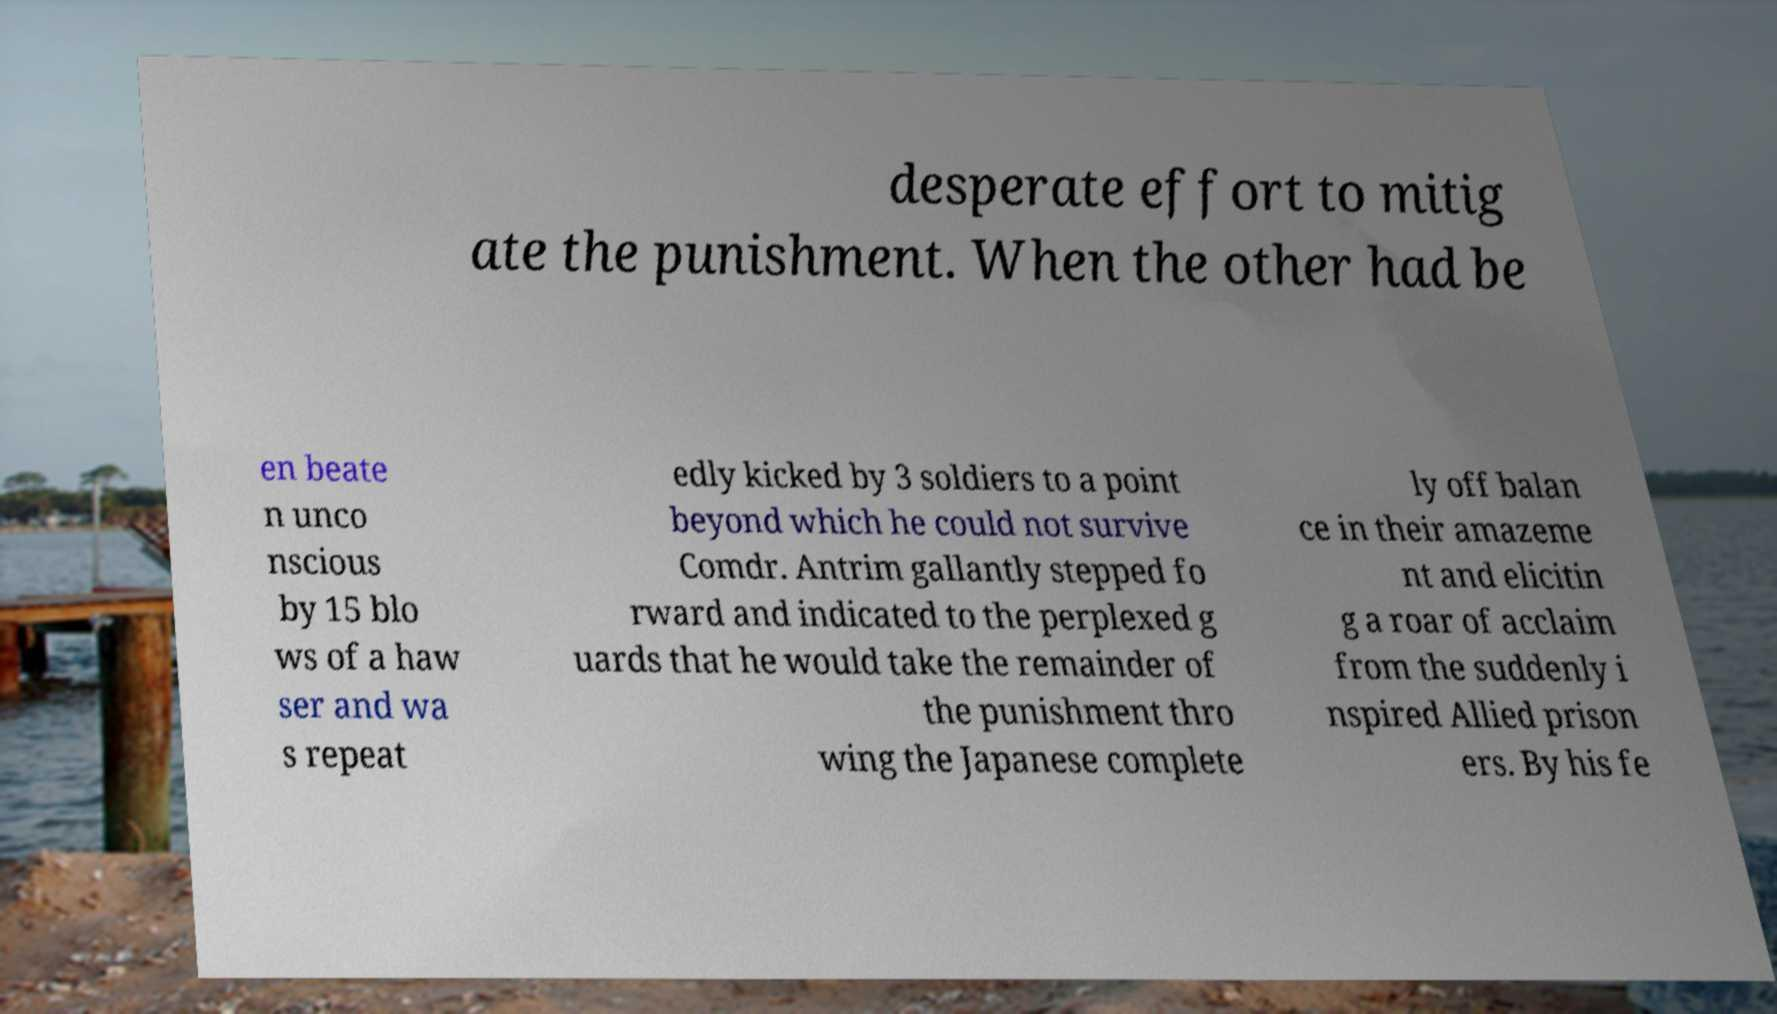There's text embedded in this image that I need extracted. Can you transcribe it verbatim? desperate effort to mitig ate the punishment. When the other had be en beate n unco nscious by 15 blo ws of a haw ser and wa s repeat edly kicked by 3 soldiers to a point beyond which he could not survive Comdr. Antrim gallantly stepped fo rward and indicated to the perplexed g uards that he would take the remainder of the punishment thro wing the Japanese complete ly off balan ce in their amazeme nt and elicitin g a roar of acclaim from the suddenly i nspired Allied prison ers. By his fe 